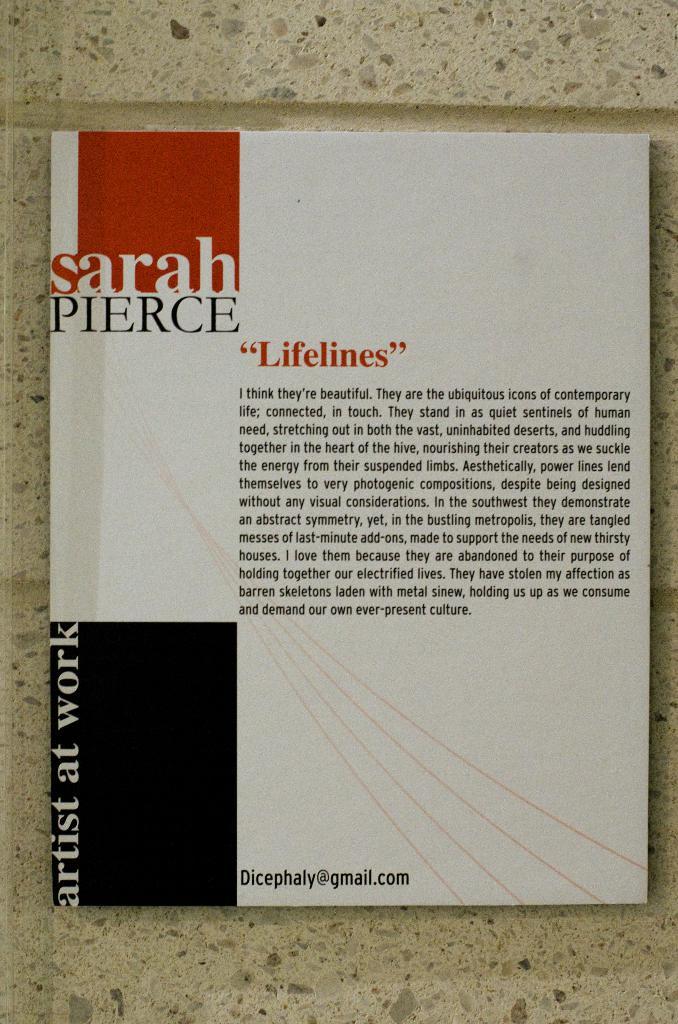What is the email listed for this artist?
Your response must be concise. Dicephaly@gmail.com. What is the text in red?
Give a very brief answer. Lifelines. 